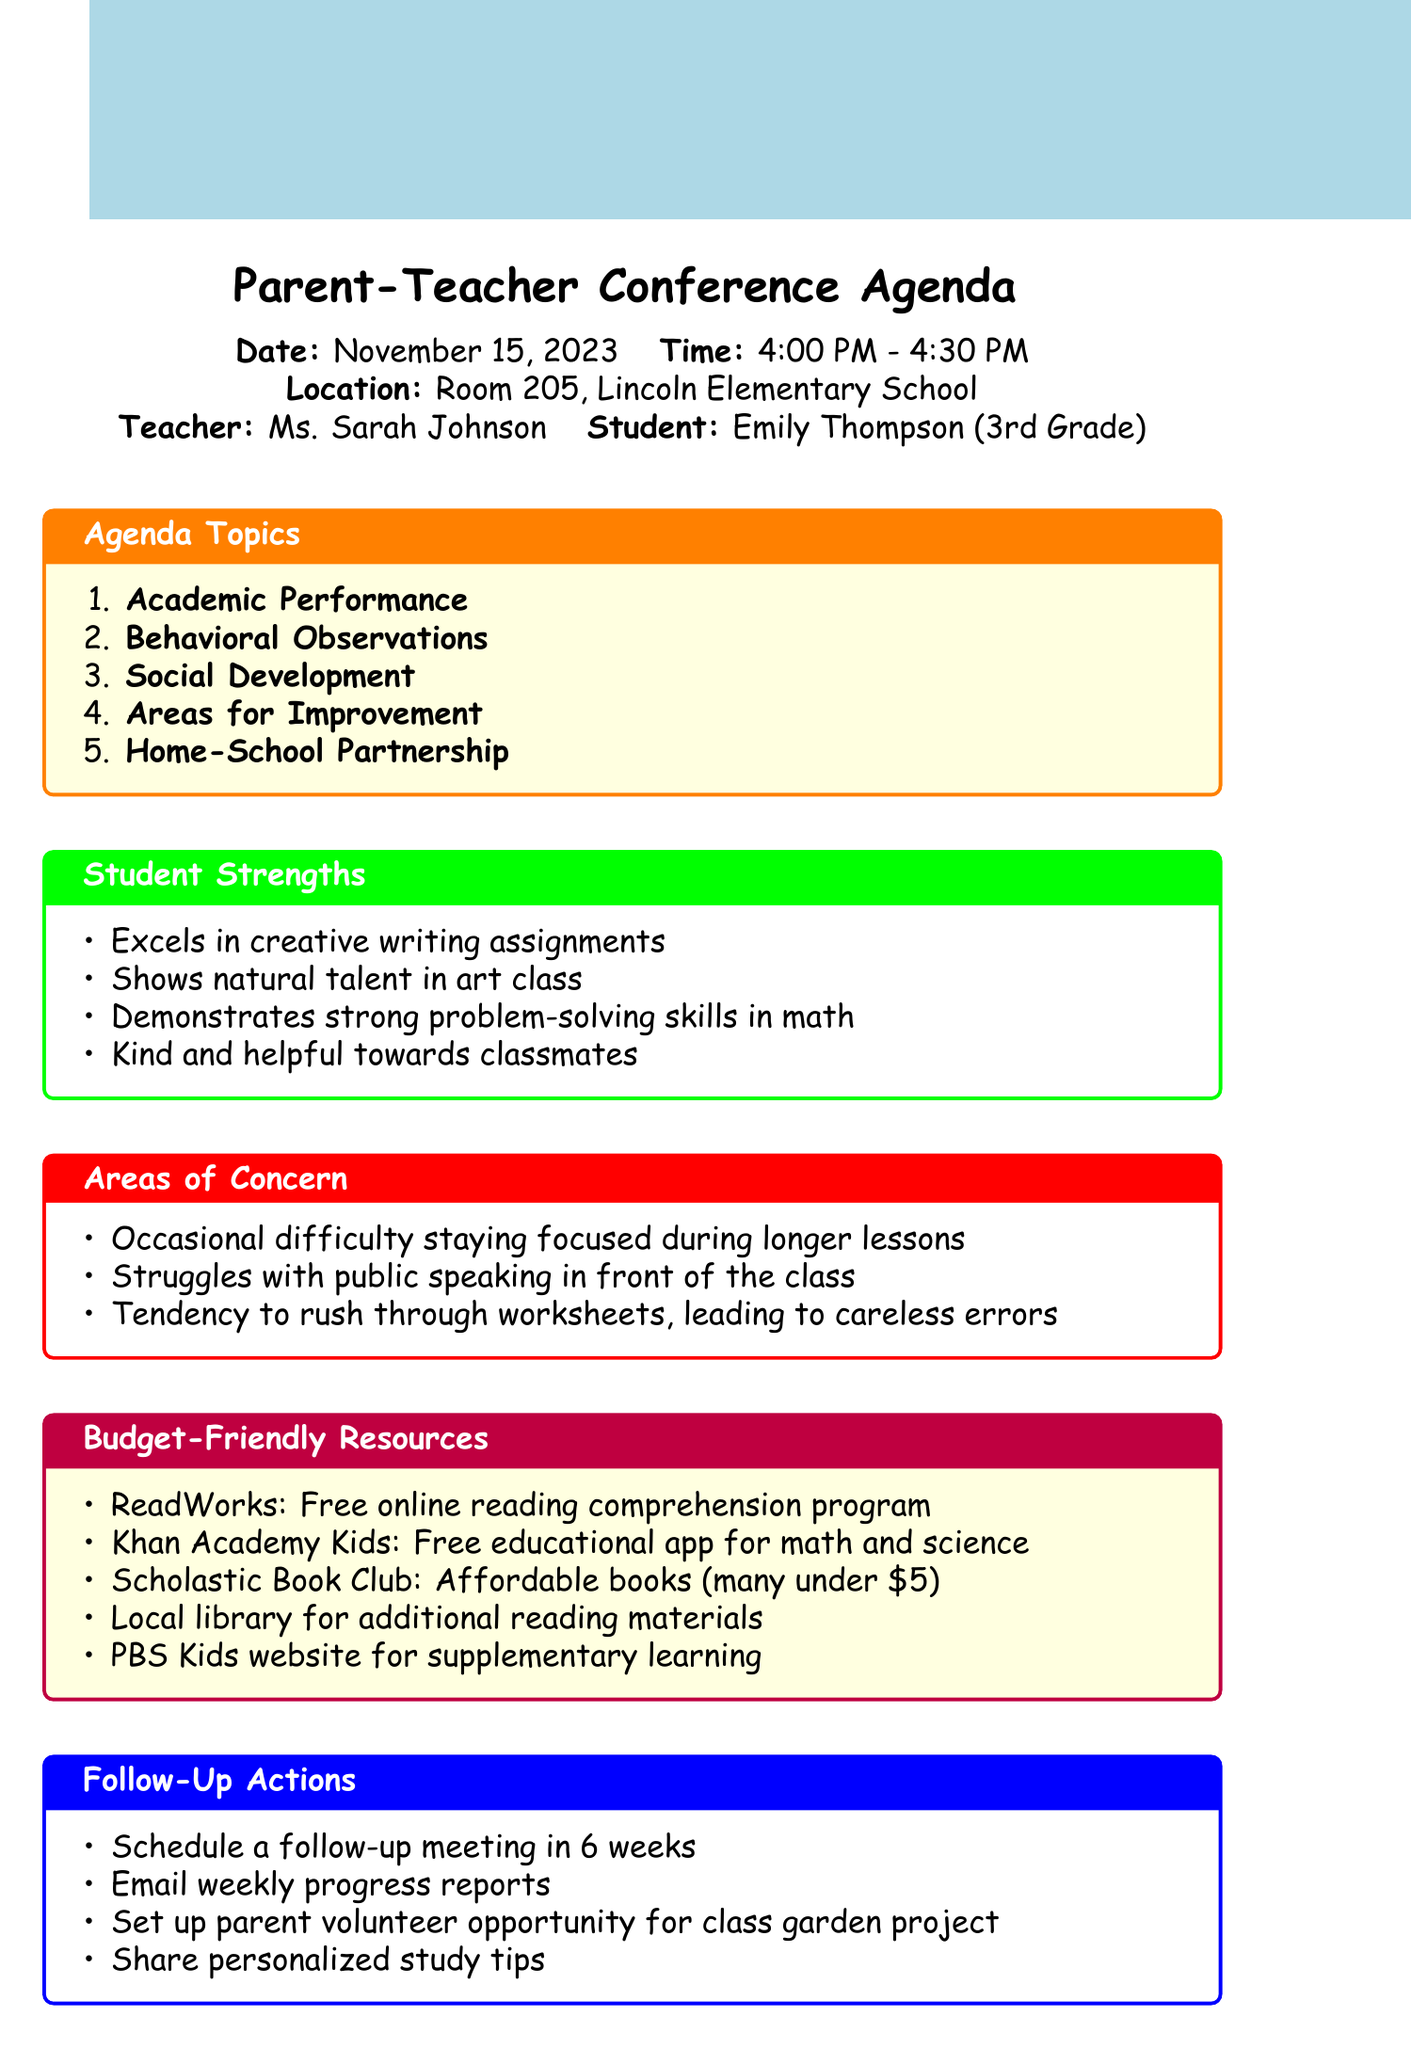What is the date of the conference? The date of the conference is explicitly mentioned in the document.
Answer: November 15, 2023 Who is the teacher for the conference? The teacher's name is provided in the conference details section.
Answer: Ms. Sarah Johnson What are the subtopics under Behavioral Observations? The subtopics are listed and include various aspects of Emily's behavior in class.
Answer: Classroom participation and engagement, Cooperation with peers during group activities, Adherence to classroom rules and routines, Emotional regulation and conflict resolution skills Which resource is described as a free online reading comprehension program? The document lists recommended resources, and this one matches the description.
Answer: ReadWorks What area is identified as a strength for Emily? The strengths of the student are detailed, focusing on what she excels in.
Answer: Excels in creative writing assignments How long is the conference scheduled to last? The time for the conference is specified and includes the starting and ending time.
Answer: 30 minutes What follow-up action involves sending reports? The follow-up actions outline several intended steps after the conference, with one directly related to report sharing.
Answer: Email weekly progress reports What is one suggested strategy for home learning? Strategies for the home-school partnership are included, and one can be directly quoted.
Answer: Establishing a consistent homework routine 